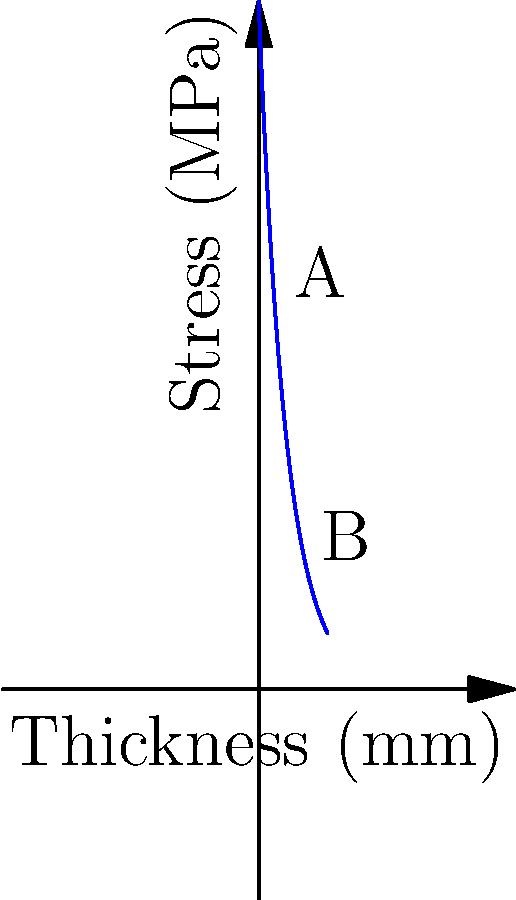A military vehicle's armor plating is being analyzed for stress distribution. The graph shows the relationship between armor thickness and stress experienced. If the current armor thickness is at point A, what percentage reduction in stress would be achieved by increasing the thickness to point B? To solve this problem, we need to follow these steps:

1. Identify the stress values at points A and B:
   Point A (10 mm): $f(10) = 500 * e^{-0.05 * 10} \approx 303.26$ MPa
   Point B (30 mm): $f(30) = 500 * e^{-0.05 * 30} \approx 111.57$ MPa

2. Calculate the difference in stress:
   $\Delta \text{Stress} = 303.26 - 111.57 = 191.69$ MPa

3. Calculate the percentage reduction:
   $\text{Percentage Reduction} = \frac{\Delta \text{Stress}}{\text{Initial Stress}} * 100\%$
   $= \frac{191.69}{303.26} * 100\% \approx 63.21\%$

This analysis shows that increasing the armor thickness from point A to point B would result in a significant stress reduction, potentially improving the vehicle's protection while considering weight trade-offs.
Answer: 63.21% 